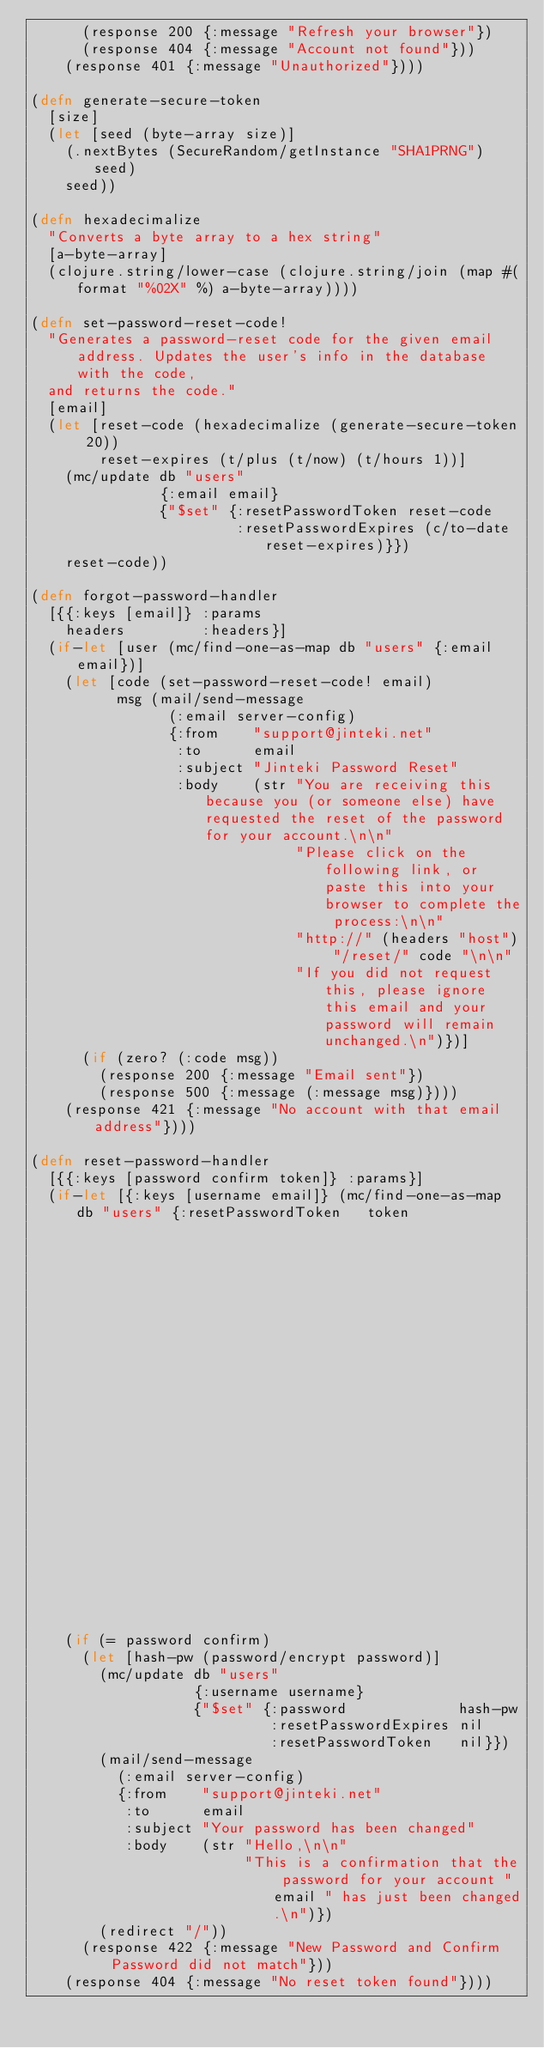Convert code to text. <code><loc_0><loc_0><loc_500><loc_500><_Clojure_>      (response 200 {:message "Refresh your browser"})
      (response 404 {:message "Account not found"}))
    (response 401 {:message "Unauthorized"})))

(defn generate-secure-token
  [size]
  (let [seed (byte-array size)]
    (.nextBytes (SecureRandom/getInstance "SHA1PRNG") seed)
    seed))

(defn hexadecimalize
  "Converts a byte array to a hex string"
  [a-byte-array]
  (clojure.string/lower-case (clojure.string/join (map #(format "%02X" %) a-byte-array))))

(defn set-password-reset-code!
  "Generates a password-reset code for the given email address. Updates the user's info in the database with the code,
  and returns the code."
  [email]
  (let [reset-code (hexadecimalize (generate-secure-token 20))
        reset-expires (t/plus (t/now) (t/hours 1))]
    (mc/update db "users"
               {:email email}
               {"$set" {:resetPasswordToken reset-code
                        :resetPasswordExpires (c/to-date reset-expires)}})
    reset-code))

(defn forgot-password-handler
  [{{:keys [email]} :params
    headers         :headers}]
  (if-let [user (mc/find-one-as-map db "users" {:email email})]
    (let [code (set-password-reset-code! email)
          msg (mail/send-message
                (:email server-config)
                {:from    "support@jinteki.net"
                 :to      email
                 :subject "Jinteki Password Reset"
                 :body    (str "You are receiving this because you (or someone else) have requested the reset of the password for your account.\n\n"
                               "Please click on the following link, or paste this into your browser to complete the process:\n\n"
                               "http://" (headers "host") "/reset/" code "\n\n"
                               "If you did not request this, please ignore this email and your password will remain unchanged.\n")})]
      (if (zero? (:code msg))
        (response 200 {:message "Email sent"})
        (response 500 {:message (:message msg)})))
    (response 421 {:message "No account with that email address"})))

(defn reset-password-handler
  [{{:keys [password confirm token]} :params}]
  (if-let [{:keys [username email]} (mc/find-one-as-map db "users" {:resetPasswordToken   token
                                                                    :resetPasswordExpires {"$gt" (c/to-date (t/now))}})]
    (if (= password confirm)
      (let [hash-pw (password/encrypt password)]
        (mc/update db "users"
                   {:username username}
                   {"$set" {:password             hash-pw
                            :resetPasswordExpires nil
                            :resetPasswordToken   nil}})
        (mail/send-message
          (:email server-config)
          {:from    "support@jinteki.net"
           :to      email
           :subject "Your password has been changed"
           :body    (str "Hello,\n\n"
                         "This is a confirmation that the password for your account " email " has just been changed.\n")})
        (redirect "/"))
      (response 422 {:message "New Password and Confirm Password did not match"}))
    (response 404 {:message "No reset token found"})))
</code> 